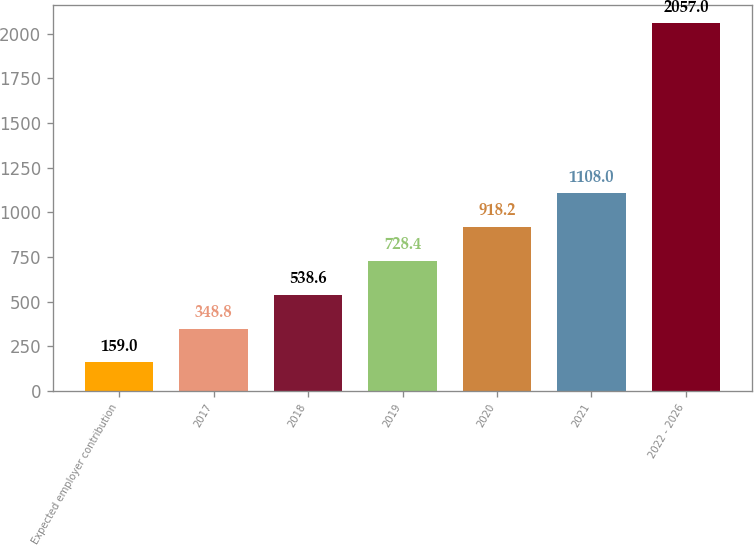Convert chart to OTSL. <chart><loc_0><loc_0><loc_500><loc_500><bar_chart><fcel>Expected employer contribution<fcel>2017<fcel>2018<fcel>2019<fcel>2020<fcel>2021<fcel>2022 - 2026<nl><fcel>159<fcel>348.8<fcel>538.6<fcel>728.4<fcel>918.2<fcel>1108<fcel>2057<nl></chart> 